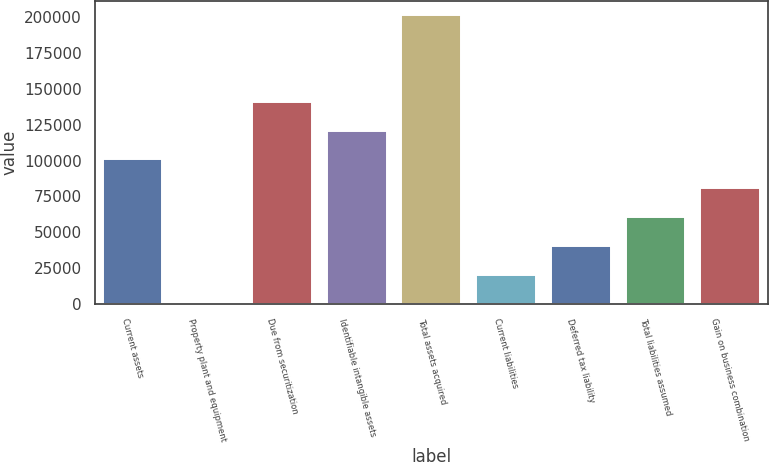Convert chart. <chart><loc_0><loc_0><loc_500><loc_500><bar_chart><fcel>Current assets<fcel>Property plant and equipment<fcel>Due from securitization<fcel>Identifiable intangible assets<fcel>Total assets acquired<fcel>Current liabilities<fcel>Deferred tax liability<fcel>Total liabilities assumed<fcel>Gain on business combination<nl><fcel>100823<fcel>491<fcel>140956<fcel>120889<fcel>201155<fcel>20557.4<fcel>40623.8<fcel>60690.2<fcel>80756.6<nl></chart> 